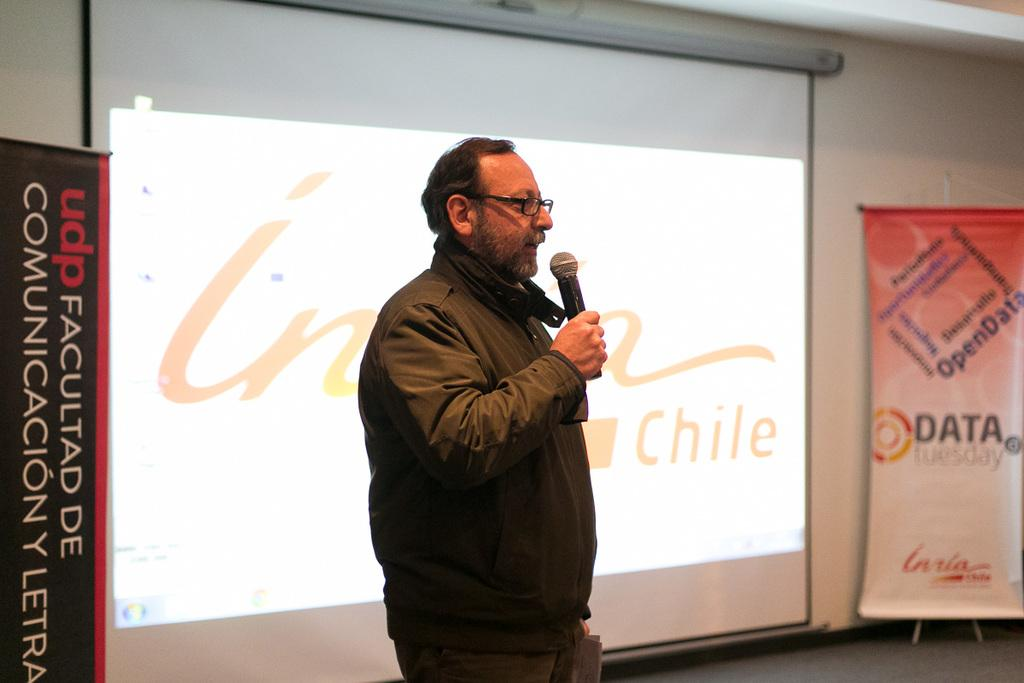<image>
Present a compact description of the photo's key features. A casually dressed middle age man is speaking in front of a screen at an event about open data. 